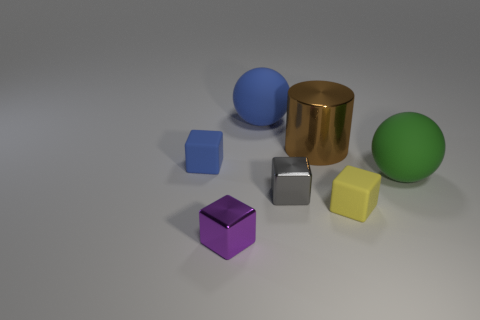Subtract all small yellow cubes. How many cubes are left? 3 Add 2 tiny yellow blocks. How many objects exist? 9 Subtract all purple cubes. How many cubes are left? 3 Subtract 3 blocks. How many blocks are left? 1 Subtract all spheres. How many objects are left? 5 Subtract all big purple metal objects. Subtract all large blue rubber balls. How many objects are left? 6 Add 3 big blue balls. How many big blue balls are left? 4 Add 2 red objects. How many red objects exist? 2 Subtract 1 gray cubes. How many objects are left? 6 Subtract all brown blocks. Subtract all brown balls. How many blocks are left? 4 